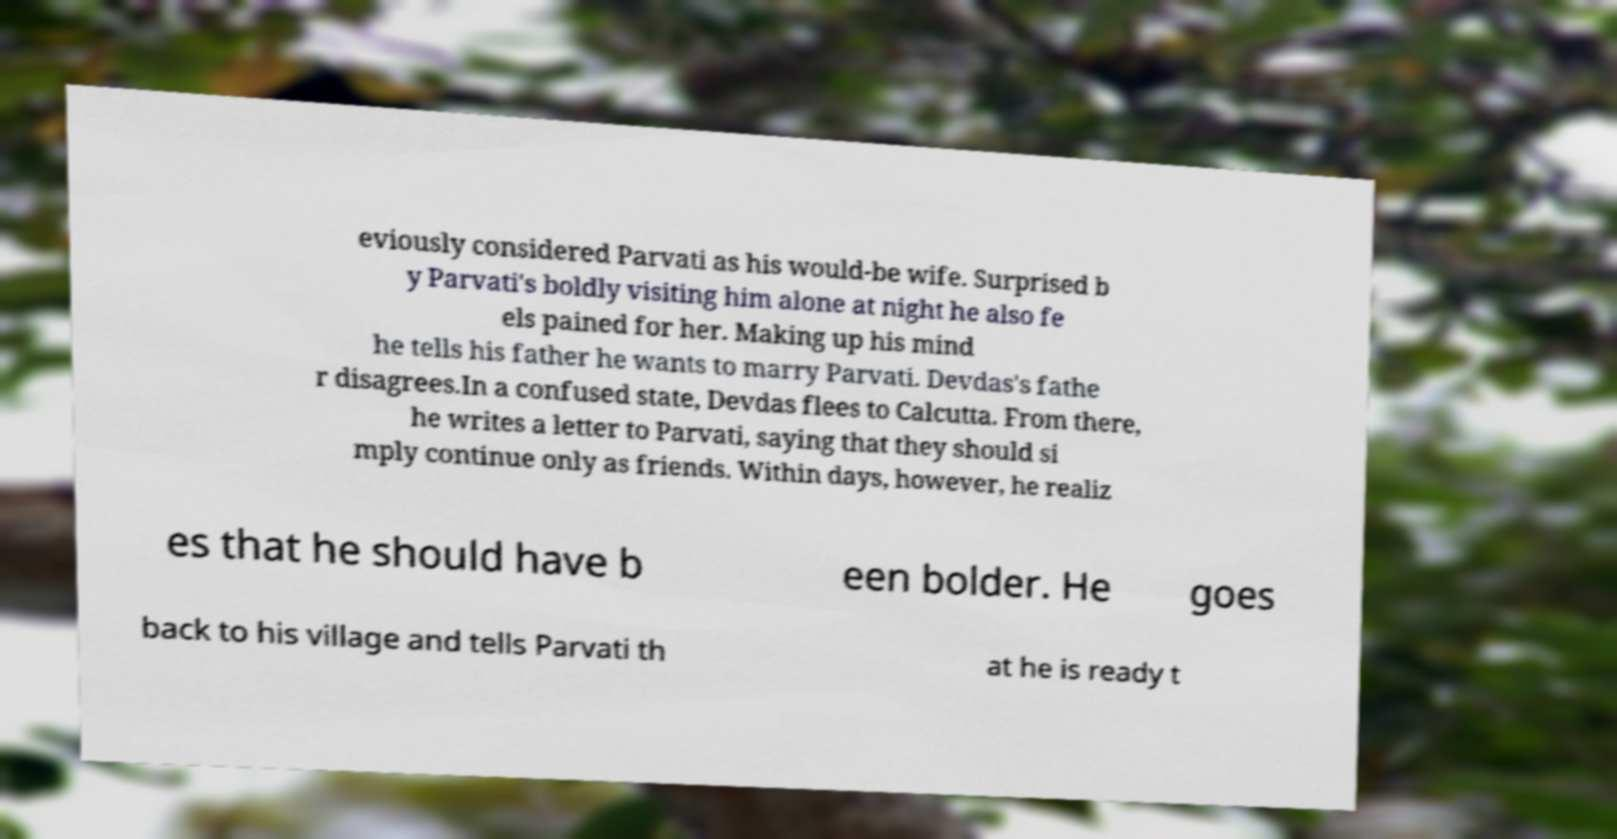I need the written content from this picture converted into text. Can you do that? eviously considered Parvati as his would-be wife. Surprised b y Parvati's boldly visiting him alone at night he also fe els pained for her. Making up his mind he tells his father he wants to marry Parvati. Devdas's fathe r disagrees.In a confused state, Devdas flees to Calcutta. From there, he writes a letter to Parvati, saying that they should si mply continue only as friends. Within days, however, he realiz es that he should have b een bolder. He goes back to his village and tells Parvati th at he is ready t 